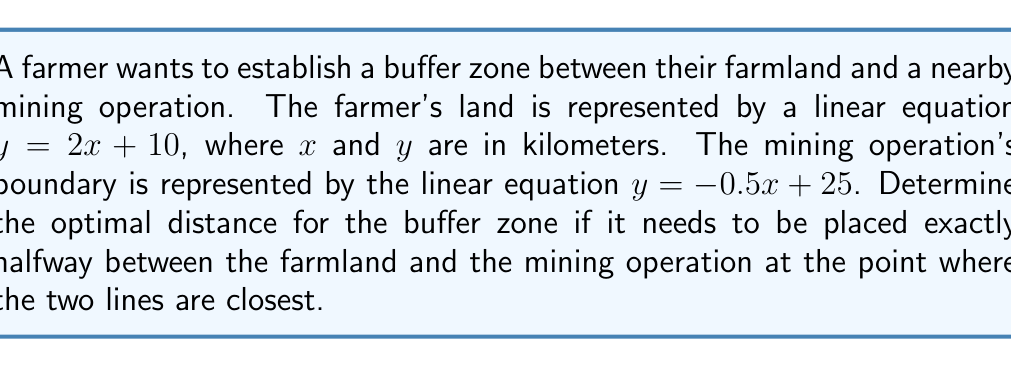Give your solution to this math problem. 1) First, we need to find the point of intersection of the two lines:
   $2x + 10 = -0.5x + 25$
   $2.5x = 15$
   $x = 6$
   
   Substituting this x-value into either equation:
   $y = 2(6) + 10 = 22$

   So, the point of intersection is (6, 22).

2) The midpoint of the line segment connecting the two lines at their closest point will be perpendicular to both lines. The slope of this perpendicular line is the negative reciprocal of the average of the two line slopes:

   Average slope = $\frac{2 + (-0.5)}{2} = 0.75$
   Perpendicular slope = $-\frac{1}{0.75} = -\frac{4}{3}$

3) The equation of the perpendicular line passing through (6, 22) is:
   $y - 22 = -\frac{4}{3}(x - 6)$

4) To find the points where this perpendicular line intersects our original lines, we solve:

   For the farmland line:
   $2x + 10 = -\frac{4}{3}(x - 6) + 22$
   $2x + 10 = -\frac{4}{3}x + 8 + 22$
   $\frac{10}{3}x = 20$
   $x = 6$
   $y = 22$

   For the mining operation line:
   $-0.5x + 25 = -\frac{4}{3}(x - 6) + 22$
   $-0.5x + 25 = -\frac{4}{3}x + 8 + 22$
   $\frac{5}{6}x = 5$
   $x = 6$
   $y = 22$

5) The buffer zone should be placed at the midpoint between these two points. However, since both points are (6, 22), this is already the optimal location for the buffer zone.

6) The distance from (6, 22) to either line is 0, so the buffer zone has an optimal width of 0.
Answer: 0 km 